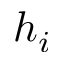<formula> <loc_0><loc_0><loc_500><loc_500>h _ { i }</formula> 